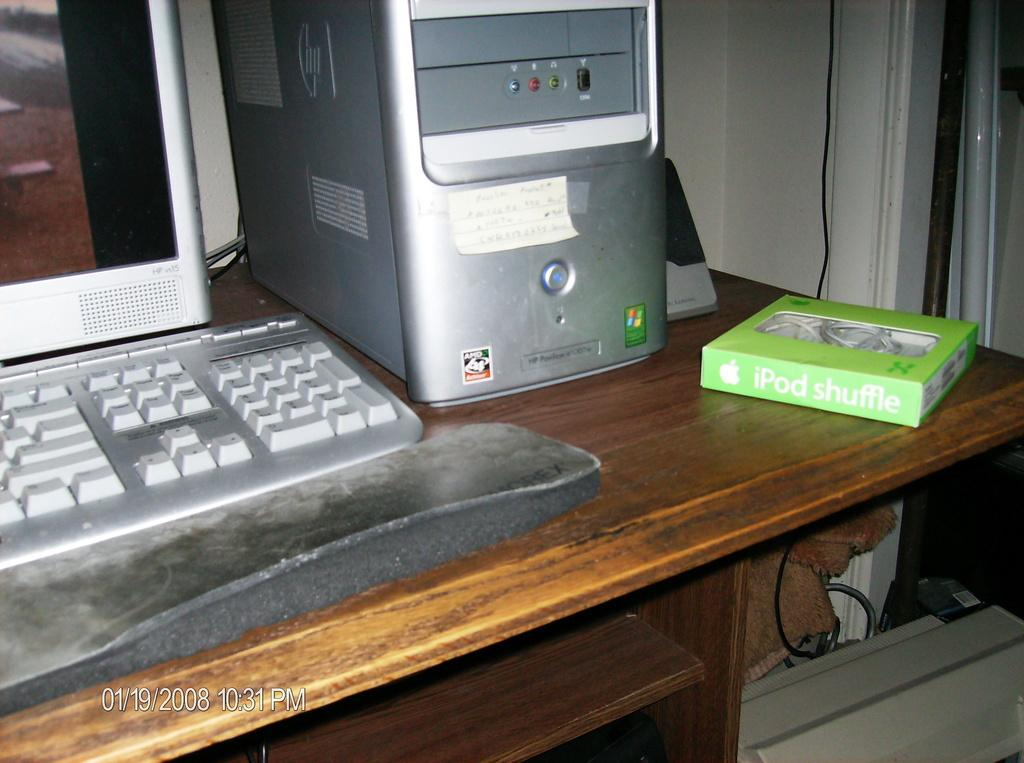<image>
Summarize the visual content of the image. A vintage silver computer with a neon green Ipod shuffle box next to it. 